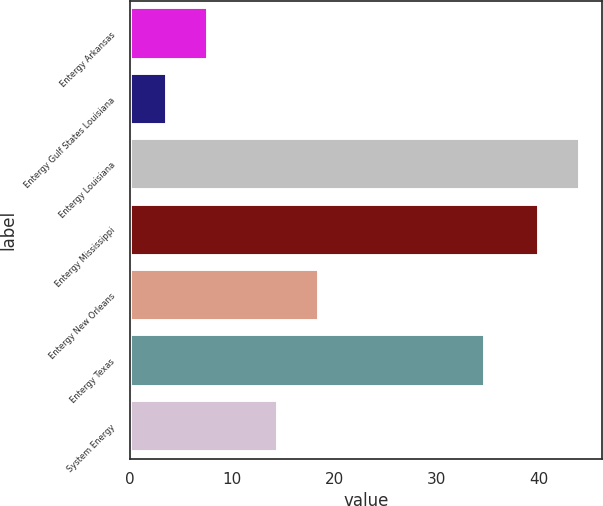Convert chart. <chart><loc_0><loc_0><loc_500><loc_500><bar_chart><fcel>Entergy Arkansas<fcel>Entergy Gulf States Louisiana<fcel>Entergy Louisiana<fcel>Entergy Mississippi<fcel>Entergy New Orleans<fcel>Entergy Texas<fcel>System Energy<nl><fcel>7.59<fcel>3.6<fcel>43.99<fcel>40<fcel>18.49<fcel>34.7<fcel>14.5<nl></chart> 